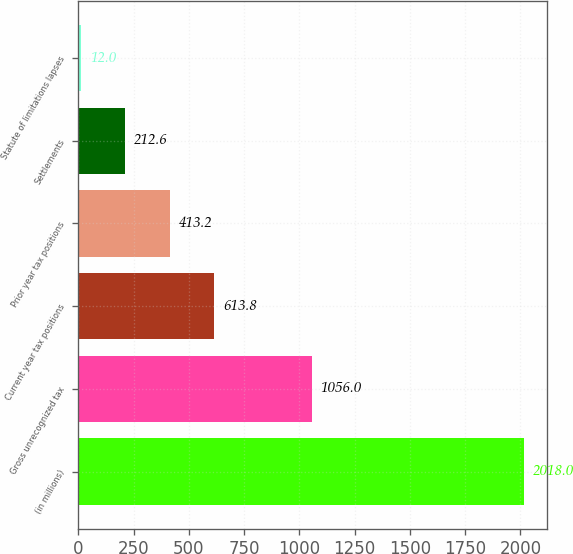Convert chart. <chart><loc_0><loc_0><loc_500><loc_500><bar_chart><fcel>(in millions)<fcel>Gross unrecognized tax<fcel>Current year tax positions<fcel>Prior year tax positions<fcel>Settlements<fcel>Statute of limitations lapses<nl><fcel>2018<fcel>1056<fcel>613.8<fcel>413.2<fcel>212.6<fcel>12<nl></chart> 